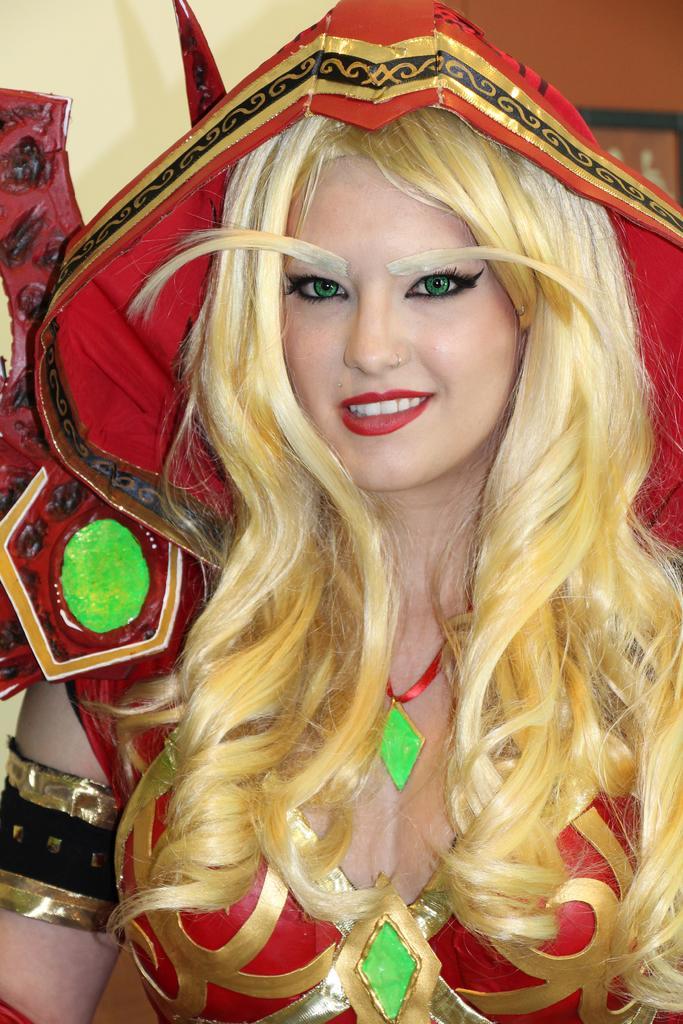Please provide a concise description of this image. In this image, we can see a person wearing fancy dress which is colored red. 